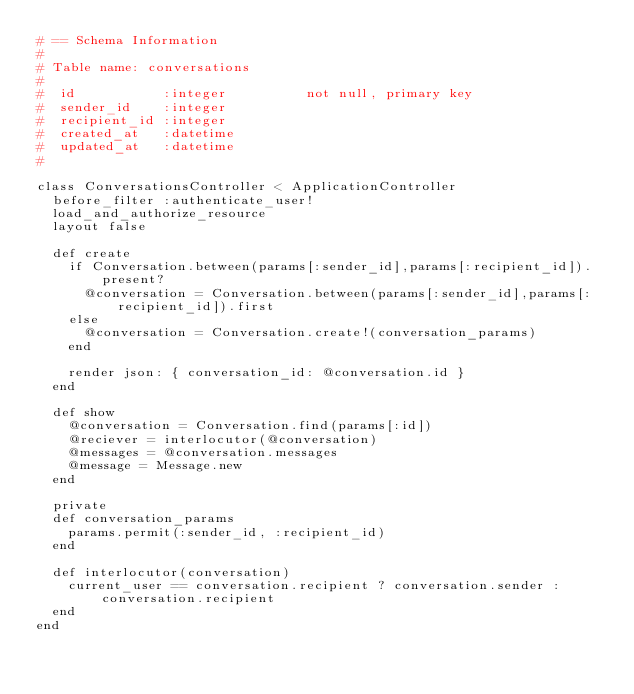Convert code to text. <code><loc_0><loc_0><loc_500><loc_500><_Ruby_># == Schema Information
#
# Table name: conversations
#
#  id           :integer          not null, primary key
#  sender_id    :integer
#  recipient_id :integer
#  created_at   :datetime
#  updated_at   :datetime
#

class ConversationsController < ApplicationController
  before_filter :authenticate_user!
  load_and_authorize_resource
  layout false

  def create
    if Conversation.between(params[:sender_id],params[:recipient_id]).present?
      @conversation = Conversation.between(params[:sender_id],params[:recipient_id]).first
    else
      @conversation = Conversation.create!(conversation_params)
    end

    render json: { conversation_id: @conversation.id }
  end

  def show
    @conversation = Conversation.find(params[:id])
    @reciever = interlocutor(@conversation)
    @messages = @conversation.messages
    @message = Message.new
  end

  private
  def conversation_params
    params.permit(:sender_id, :recipient_id)
  end

  def interlocutor(conversation)
    current_user == conversation.recipient ? conversation.sender : conversation.recipient
  end
end
</code> 